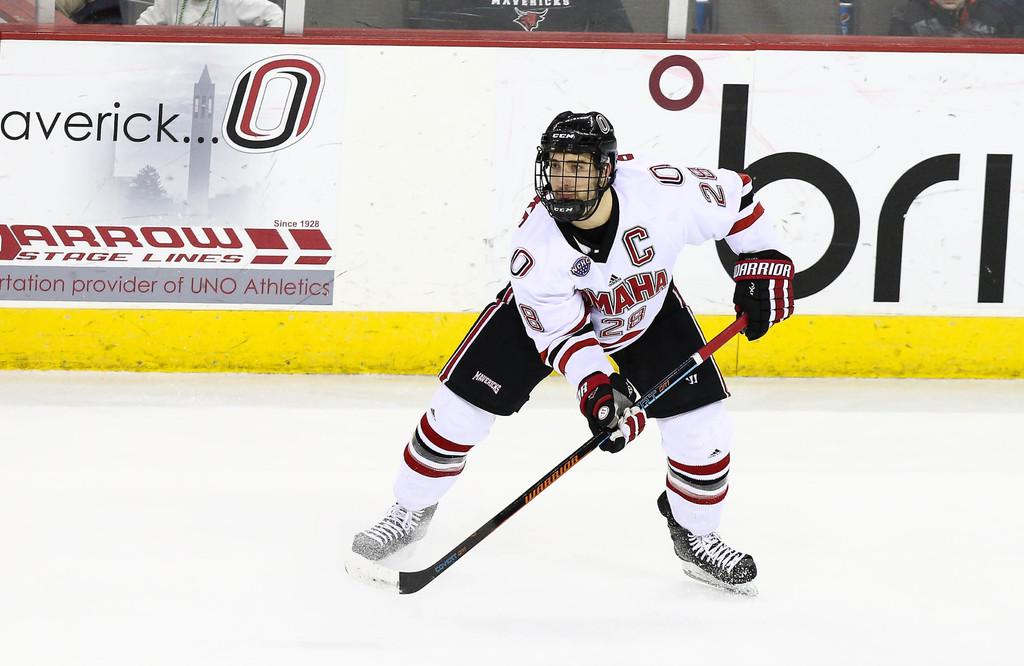<image>
Relay a brief, clear account of the picture shown. a hockey player with a C on their jersey 